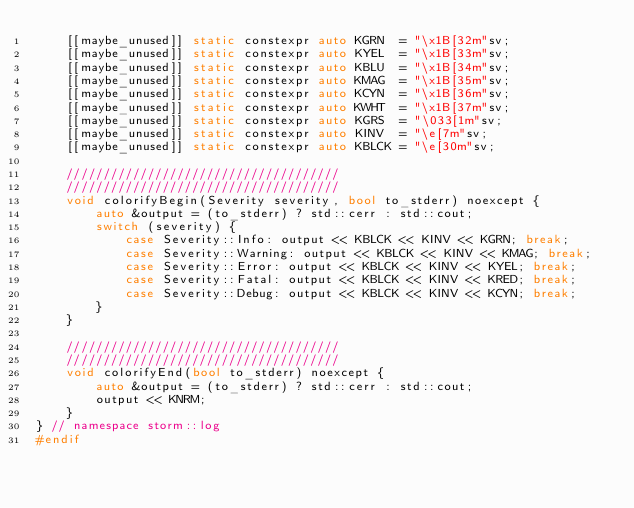Convert code to text. <code><loc_0><loc_0><loc_500><loc_500><_C++_>    [[maybe_unused]] static constexpr auto KGRN  = "\x1B[32m"sv;
    [[maybe_unused]] static constexpr auto KYEL  = "\x1B[33m"sv;
    [[maybe_unused]] static constexpr auto KBLU  = "\x1B[34m"sv;
    [[maybe_unused]] static constexpr auto KMAG  = "\x1B[35m"sv;
    [[maybe_unused]] static constexpr auto KCYN  = "\x1B[36m"sv;
    [[maybe_unused]] static constexpr auto KWHT  = "\x1B[37m"sv;
    [[maybe_unused]] static constexpr auto KGRS  = "\033[1m"sv;
    [[maybe_unused]] static constexpr auto KINV  = "\e[7m"sv;
    [[maybe_unused]] static constexpr auto KBLCK = "\e[30m"sv;

    /////////////////////////////////////
    /////////////////////////////////////
    void colorifyBegin(Severity severity, bool to_stderr) noexcept {
        auto &output = (to_stderr) ? std::cerr : std::cout;
        switch (severity) {
            case Severity::Info: output << KBLCK << KINV << KGRN; break;
            case Severity::Warning: output << KBLCK << KINV << KMAG; break;
            case Severity::Error: output << KBLCK << KINV << KYEL; break;
            case Severity::Fatal: output << KBLCK << KINV << KRED; break;
            case Severity::Debug: output << KBLCK << KINV << KCYN; break;
        }
    }

    /////////////////////////////////////
    /////////////////////////////////////
    void colorifyEnd(bool to_stderr) noexcept {
        auto &output = (to_stderr) ? std::cerr : std::cout;
        output << KNRM;
    }
} // namespace storm::log
#endif
</code> 